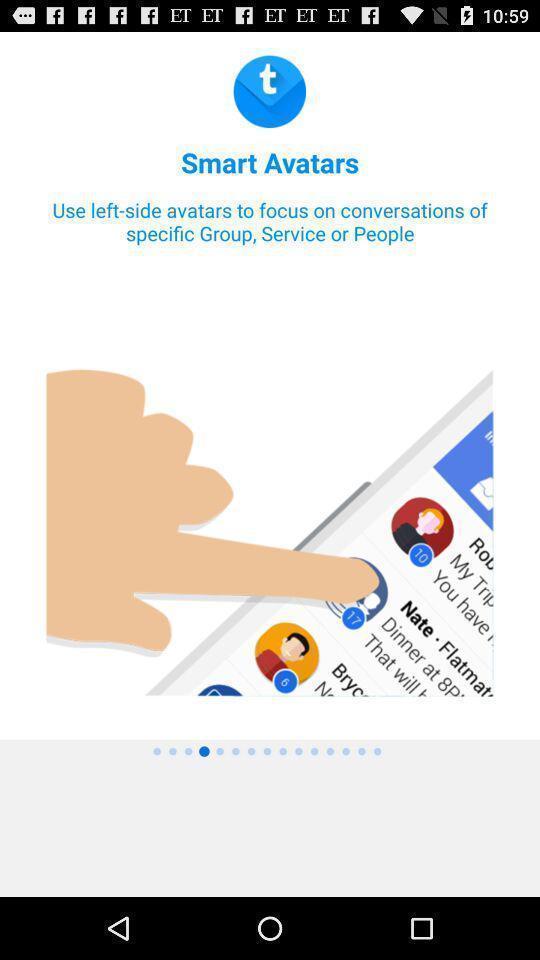Provide a textual representation of this image. Screen showing the tutorial page. 